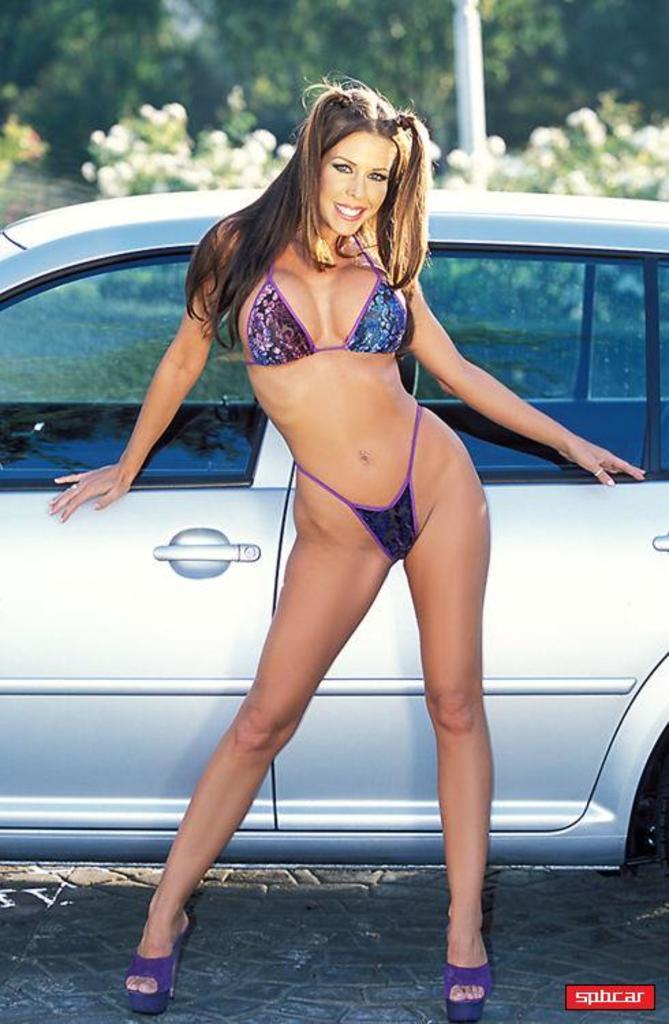Describe this image in one or two sentences. In the background we can see leaves and a white object. In this picture we can see a woman standing and giving a pose. She is smiling. We can see a car. In the bottom right corner of the picture we can see watermark. 